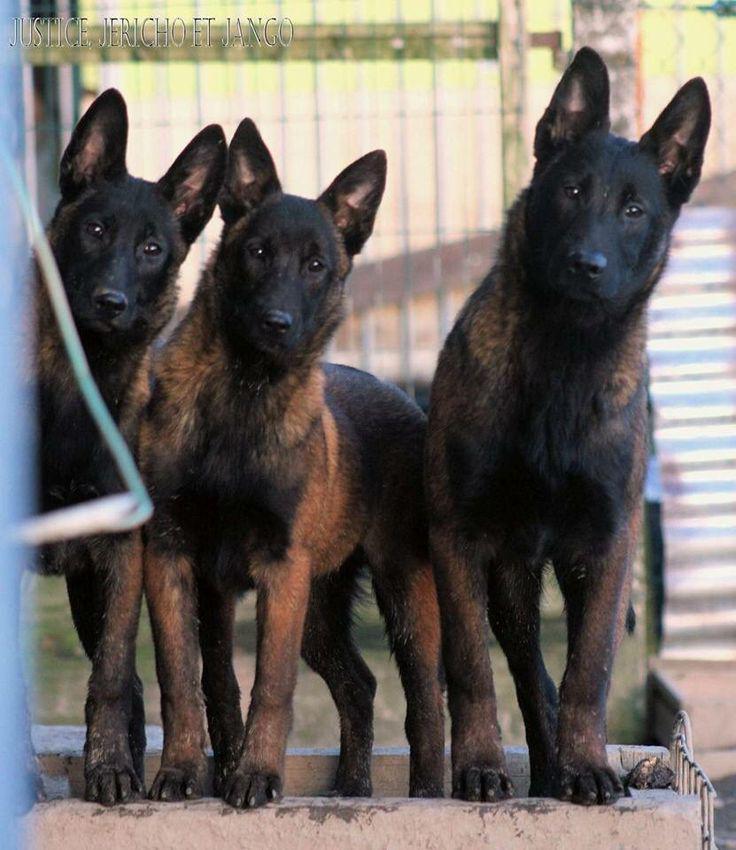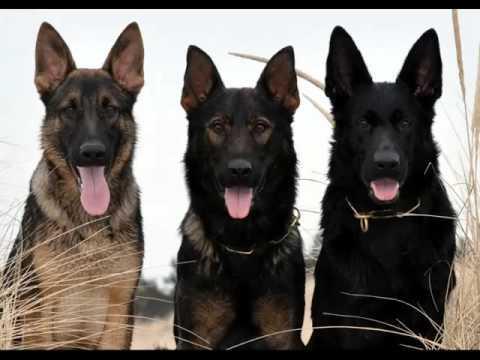The first image is the image on the left, the second image is the image on the right. Considering the images on both sides, is "There is one extended dog tongue in the image on the left." valid? Answer yes or no. No. 